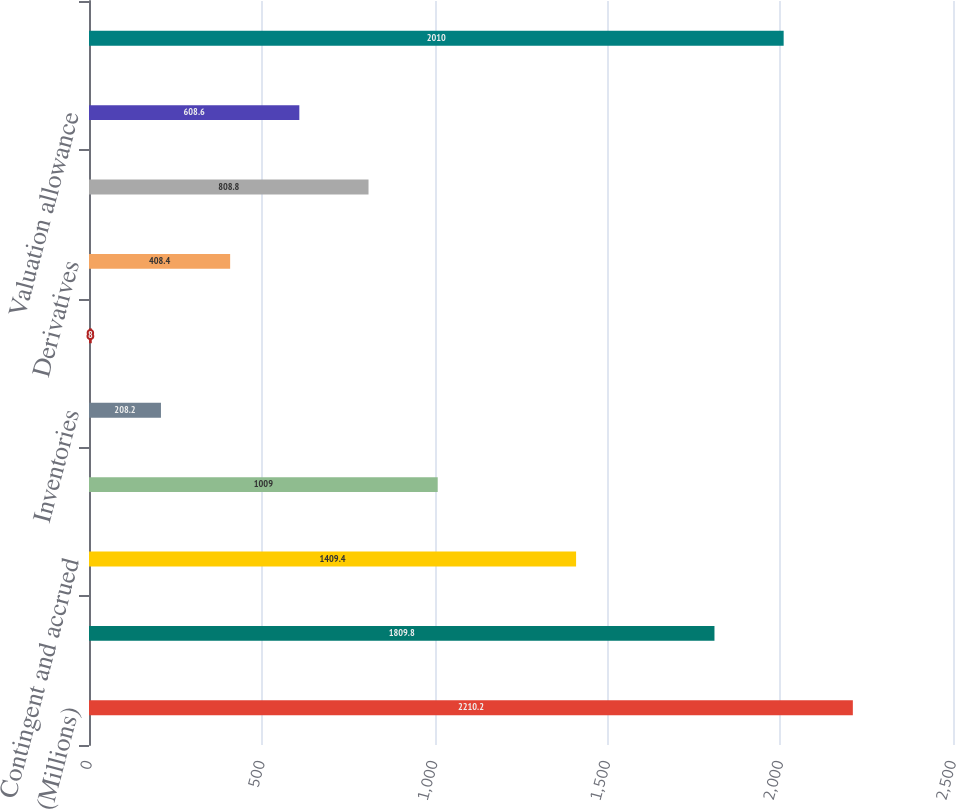Convert chart to OTSL. <chart><loc_0><loc_0><loc_500><loc_500><bar_chart><fcel>(Millions)<fcel>Employee benefits<fcel>Contingent and accrued<fcel>Operating loss and other<fcel>Inventories<fcel>Property<fcel>Derivatives<fcel>Other<fcel>Valuation allowance<fcel>Total<nl><fcel>2210.2<fcel>1809.8<fcel>1409.4<fcel>1009<fcel>208.2<fcel>8<fcel>408.4<fcel>808.8<fcel>608.6<fcel>2010<nl></chart> 